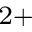Convert formula to latex. <formula><loc_0><loc_0><loc_500><loc_500>^ { 2 + }</formula> 